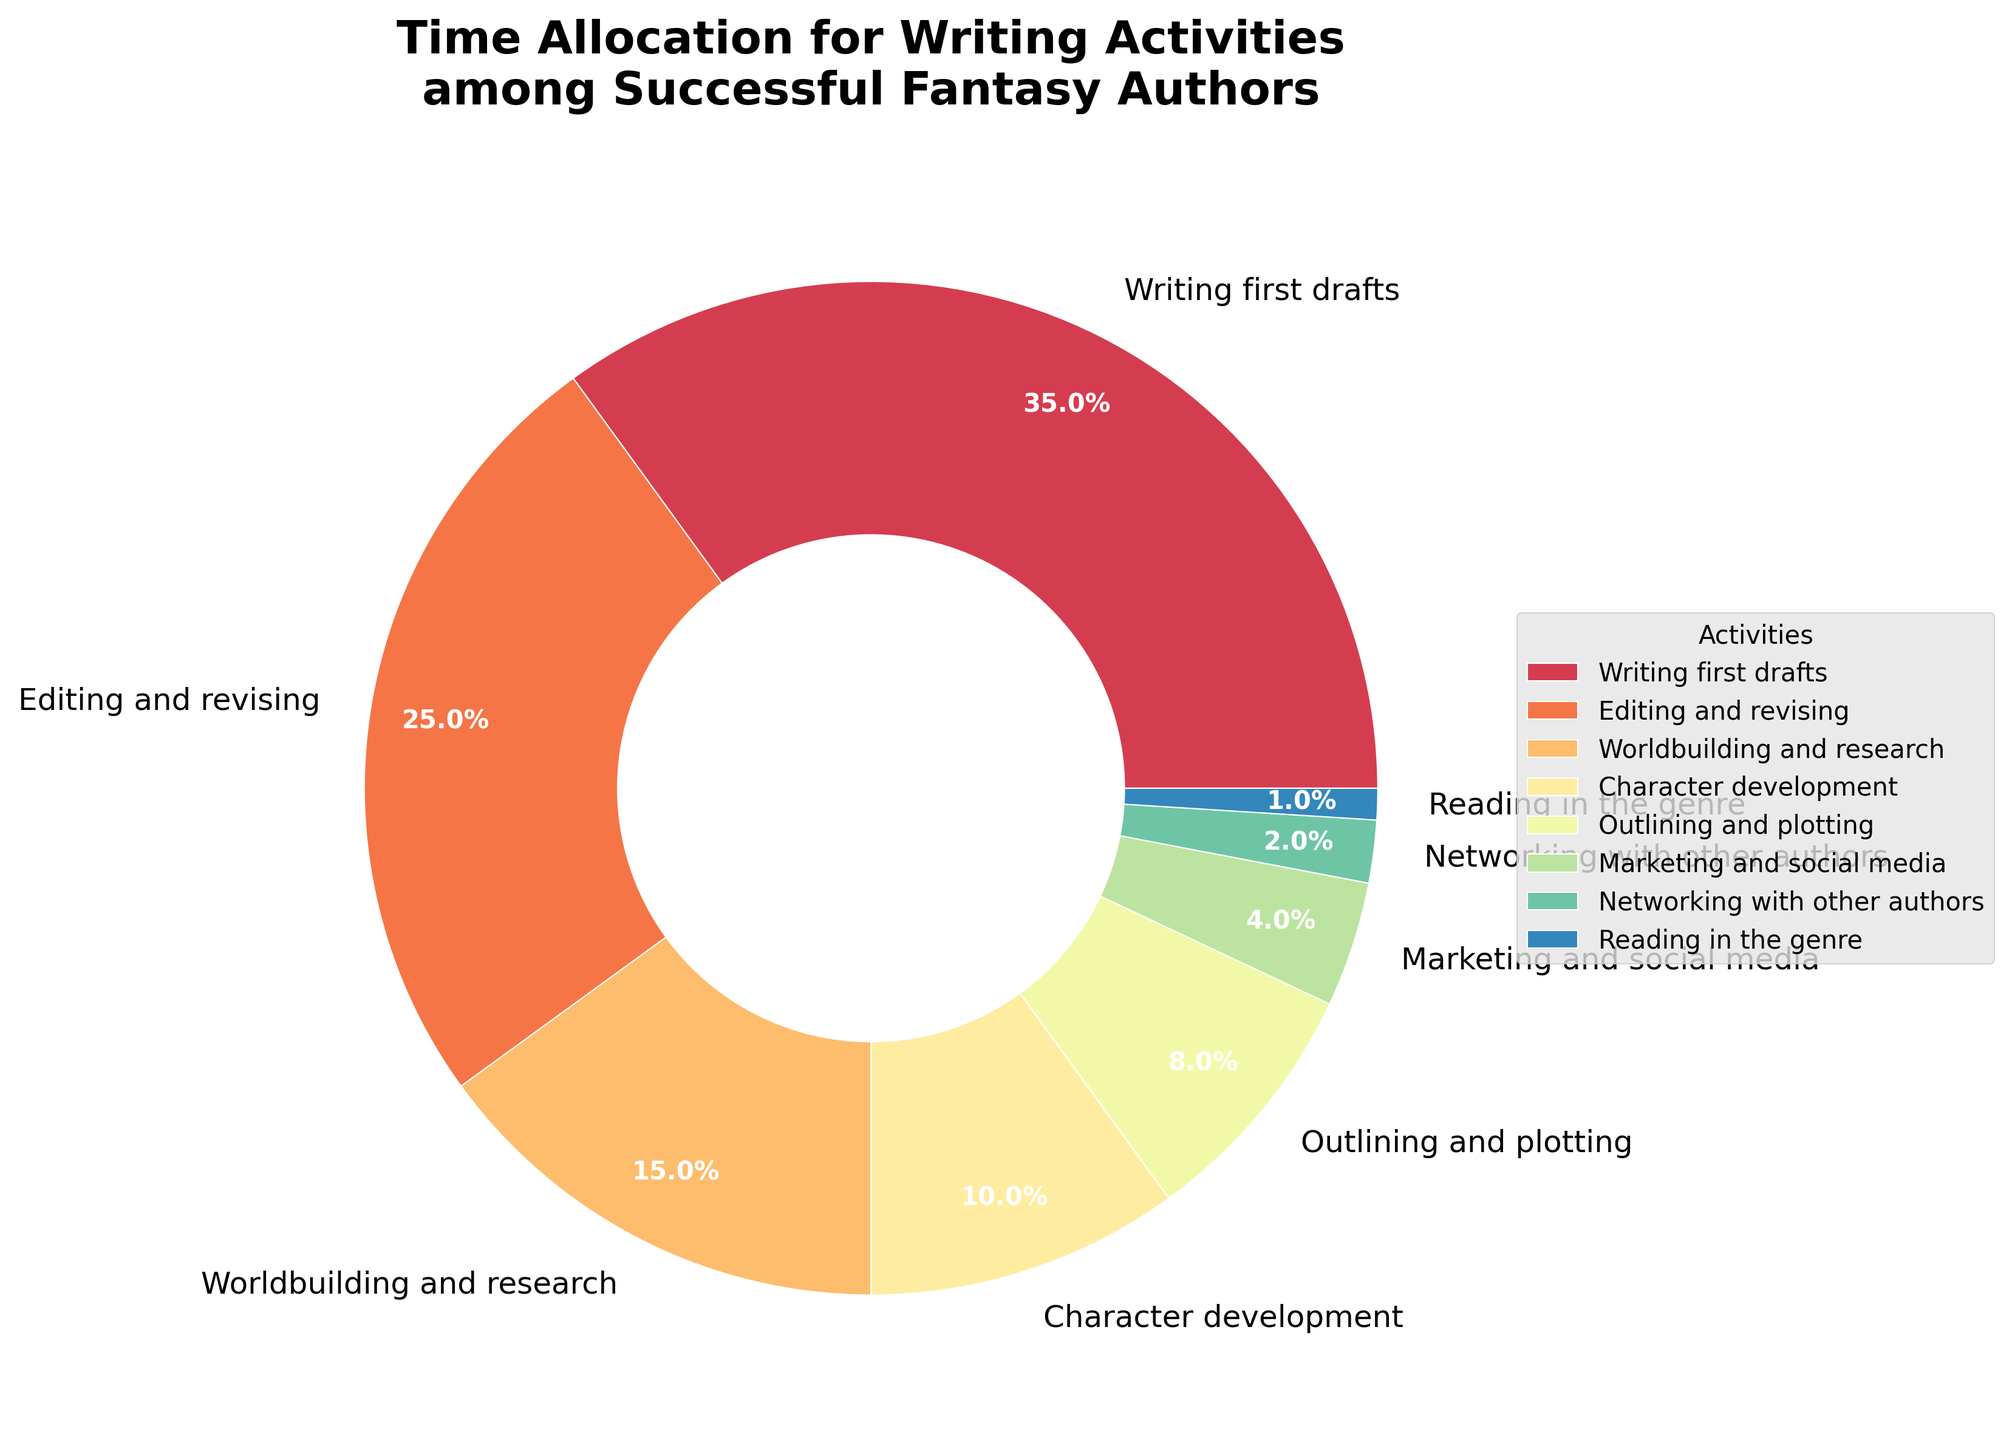What's the most time-consuming activity for successful fantasy authors? First, identify all the activities listed on the pie chart. Then, find the activity with the highest percentage value. "Writing first drafts" has the highest percentage at 35%.
Answer: Writing first drafts Which activity occupies less time than editing and revising but more time than character development? Identify the percentage values for "editing and revising" (25%) and "character development" (10%). Find the activity whose percentage falls between these two values. "Worldbuilding and research" fits this criterion with 15%.
Answer: Worldbuilding and research What is the combined time spent on networking with other authors and reading in the genre? Locate the individual percentages for "networking with other authors" (2%) and "reading in the genre" (1%). Add these percentages together: 2% + 1% = 3%.
Answer: 3% How does the time spent on outlining and plotting compare to character development? Find the percentage values for "outlining and plotting" (8%) and "character development" (10%). Compare the two values: "character development" has a higher percentage by 2%.
Answer: Character development has more time What percentage of time is allocated to activities other than writing first drafts? Writing first drafts takes 35% of the time. Subtract this from 100% to account for all other activities: 100% - 35% = 65%.
Answer: 65% Which activity's slice is visually smallest in the pie chart? Look at all the slices in the pie chart and identify the one with the smallest area. "Reading in the genre" has the smallest allocated percentage at 1%, making it the visually smallest slice.
Answer: Reading in the genre How many activities take up less than 10% of the time each? By examining the pie chart, identify all activities with slices representing less than 10% of the pie. "Outlining and plotting" (8%), "Marketing and social media" (4%), "Networking with other authors" (2%), and "Reading in the genre" (1%) all meet this criterion.
Answer: Four activities What is the total time percentage dedicated to worldbuilding, character development, and outlining? Find the percentages for "worldbuilding and research" (15%), "character development" (10%), and "outlining and plotting" (8%). Add these percentages together: 15% + 10% + 8% = 33%.
Answer: 33% Is more time spent on marketing and social media or on networking with other authors? Compare the percentage values for "marketing and social media" (4%) and "networking with other authors" (2%). More time is spent on "marketing and social media" than on "networking with other authors".
Answer: Marketing and social media 